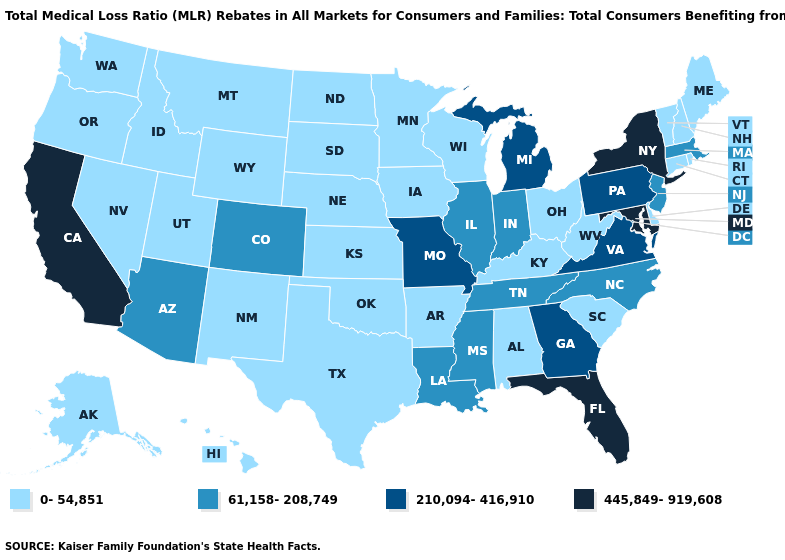What is the highest value in the USA?
Short answer required. 445,849-919,608. Among the states that border Massachusetts , which have the highest value?
Keep it brief. New York. Which states have the highest value in the USA?
Quick response, please. California, Florida, Maryland, New York. Which states have the lowest value in the USA?
Answer briefly. Alabama, Alaska, Arkansas, Connecticut, Delaware, Hawaii, Idaho, Iowa, Kansas, Kentucky, Maine, Minnesota, Montana, Nebraska, Nevada, New Hampshire, New Mexico, North Dakota, Ohio, Oklahoma, Oregon, Rhode Island, South Carolina, South Dakota, Texas, Utah, Vermont, Washington, West Virginia, Wisconsin, Wyoming. Does North Carolina have the lowest value in the USA?
Quick response, please. No. What is the lowest value in the USA?
Give a very brief answer. 0-54,851. Which states have the lowest value in the USA?
Give a very brief answer. Alabama, Alaska, Arkansas, Connecticut, Delaware, Hawaii, Idaho, Iowa, Kansas, Kentucky, Maine, Minnesota, Montana, Nebraska, Nevada, New Hampshire, New Mexico, North Dakota, Ohio, Oklahoma, Oregon, Rhode Island, South Carolina, South Dakota, Texas, Utah, Vermont, Washington, West Virginia, Wisconsin, Wyoming. Does Mississippi have a lower value than Michigan?
Short answer required. Yes. Name the states that have a value in the range 0-54,851?
Concise answer only. Alabama, Alaska, Arkansas, Connecticut, Delaware, Hawaii, Idaho, Iowa, Kansas, Kentucky, Maine, Minnesota, Montana, Nebraska, Nevada, New Hampshire, New Mexico, North Dakota, Ohio, Oklahoma, Oregon, Rhode Island, South Carolina, South Dakota, Texas, Utah, Vermont, Washington, West Virginia, Wisconsin, Wyoming. Among the states that border Georgia , does South Carolina have the highest value?
Keep it brief. No. What is the lowest value in the USA?
Keep it brief. 0-54,851. What is the value of Hawaii?
Write a very short answer. 0-54,851. Does Iowa have the lowest value in the USA?
Keep it brief. Yes. Does Utah have a higher value than Michigan?
Give a very brief answer. No. What is the value of California?
Short answer required. 445,849-919,608. 